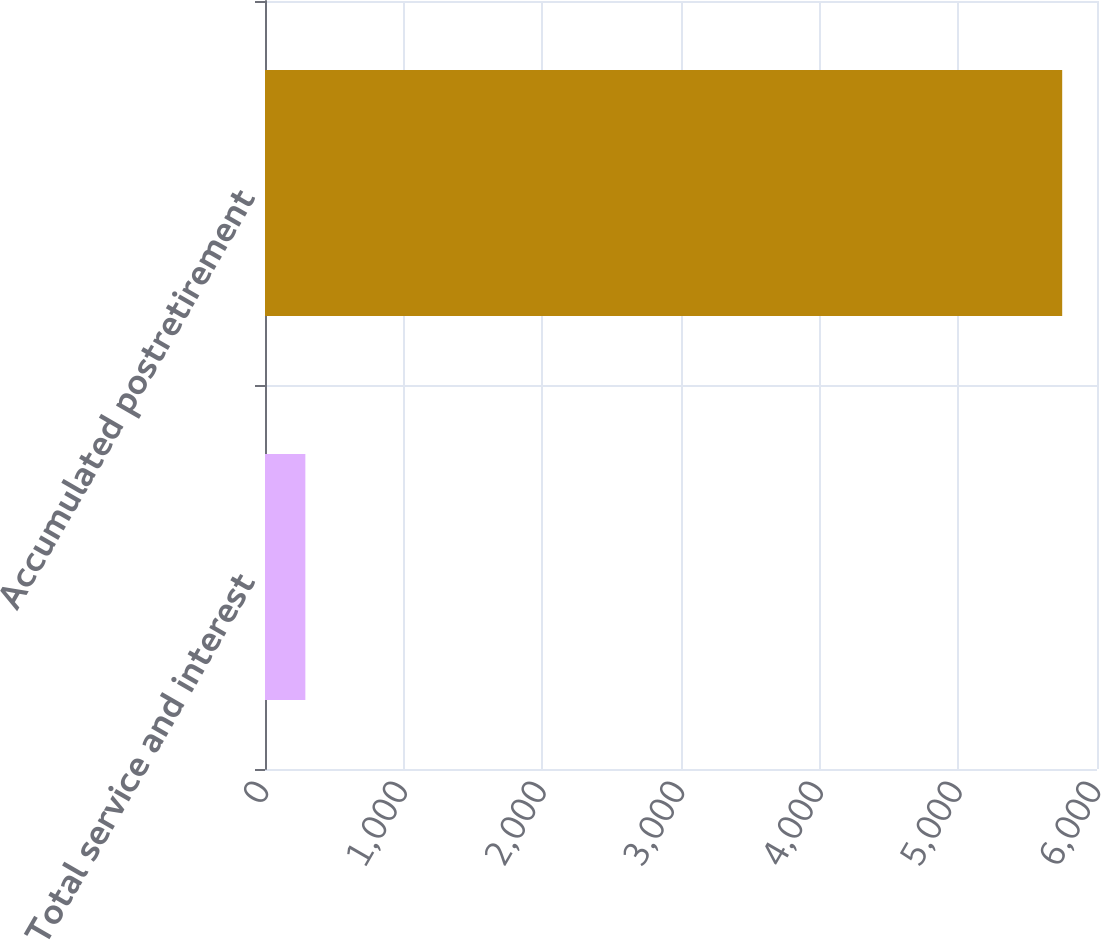Convert chart to OTSL. <chart><loc_0><loc_0><loc_500><loc_500><bar_chart><fcel>Total service and interest<fcel>Accumulated postretirement<nl><fcel>291<fcel>5749<nl></chart> 